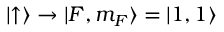<formula> <loc_0><loc_0><loc_500><loc_500>| { \uparrow } \rangle \rightarrow | { F , m _ { F } } \rangle = | { 1 , 1 } \rangle</formula> 